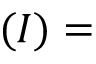Convert formula to latex. <formula><loc_0><loc_0><loc_500><loc_500>( I ) =</formula> 